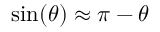<formula> <loc_0><loc_0><loc_500><loc_500>\sin ( \theta ) \approx \pi - \theta</formula> 